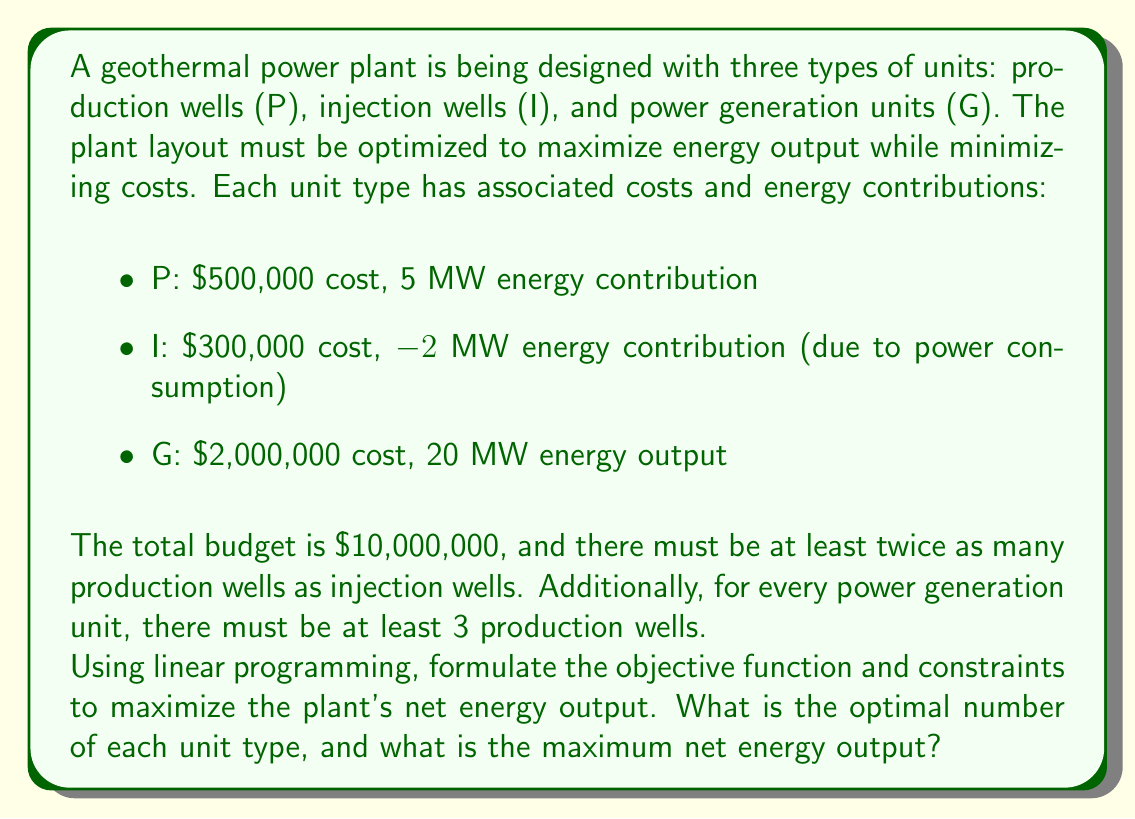Can you solve this math problem? Let's approach this step-by-step using linear programming:

1) Define variables:
   $x$ = number of production wells (P)
   $y$ = number of injection wells (I)
   $z$ = number of power generation units (G)

2) Objective function:
   We want to maximize the net energy output:
   $\text{Maximize } E = 5x - 2y + 20z$

3) Constraints:
   a) Budget constraint:
      $500,000x + 300,000y + 2,000,000z \leq 10,000,000$

   b) Relation between production and injection wells:
      $x \geq 2y$

   c) Relation between production wells and power generation units:
      $x \geq 3z$

   d) Non-negativity constraints:
      $x, y, z \geq 0$

   e) Integer constraints (as we can't have fractional units):
      $x, y, z$ are integers

4) Simplify the budget constraint:
   $5x + 3y + 20z \leq 100$

5) The complete linear programming model:

   Maximize $E = 5x - 2y + 20z$
   Subject to:
   $5x + 3y + 20z \leq 100$
   $x - 2y \geq 0$
   $x - 3z \geq 0$
   $x, y, z \geq 0$ and integers

6) Solve using a linear programming solver or by graphical method if possible. In this case, due to the integer constraints, we would typically use an integer programming solver.

7) The optimal solution is:
   $x = 12$ (production wells)
   $y = 6$ (injection wells)
   $z = 4$ (power generation units)

8) Calculate the maximum net energy output:
   $E = 5(12) - 2(6) + 20(4) = 60 - 12 + 80 = 128$ MW
Answer: The optimal layout consists of 12 production wells, 6 injection wells, and 4 power generation units, producing a maximum net energy output of 128 MW. 